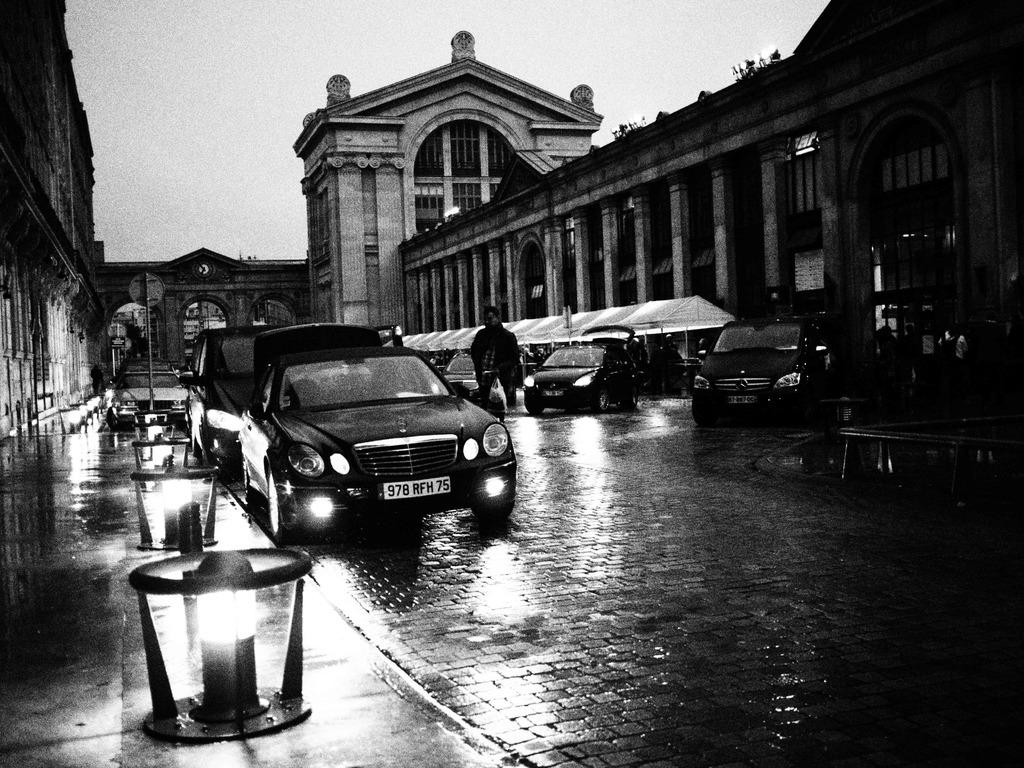What can be seen on the road in the image? There are vehicles on the road in the image. Can you describe the person in the image? There is a person in the image. What type of illumination is present in the image? There are lights in the image. What type of temporary shelters can be seen in the image? There are tents in the image. What type of structures can be seen in the image? There are buildings in the image. What other unspecified objects can be seen in the image? There are some unspecified objects in the image. What is visible in the background of the image? The sky is visible in the background of the image. What type of mint is growing near the tents in the image? There is no mint growing near the tents in the image. How many times does the person in the image need to bit their nails? The person in the image is not biting their nails, so it cannot be determined how many times they would need to do so. 